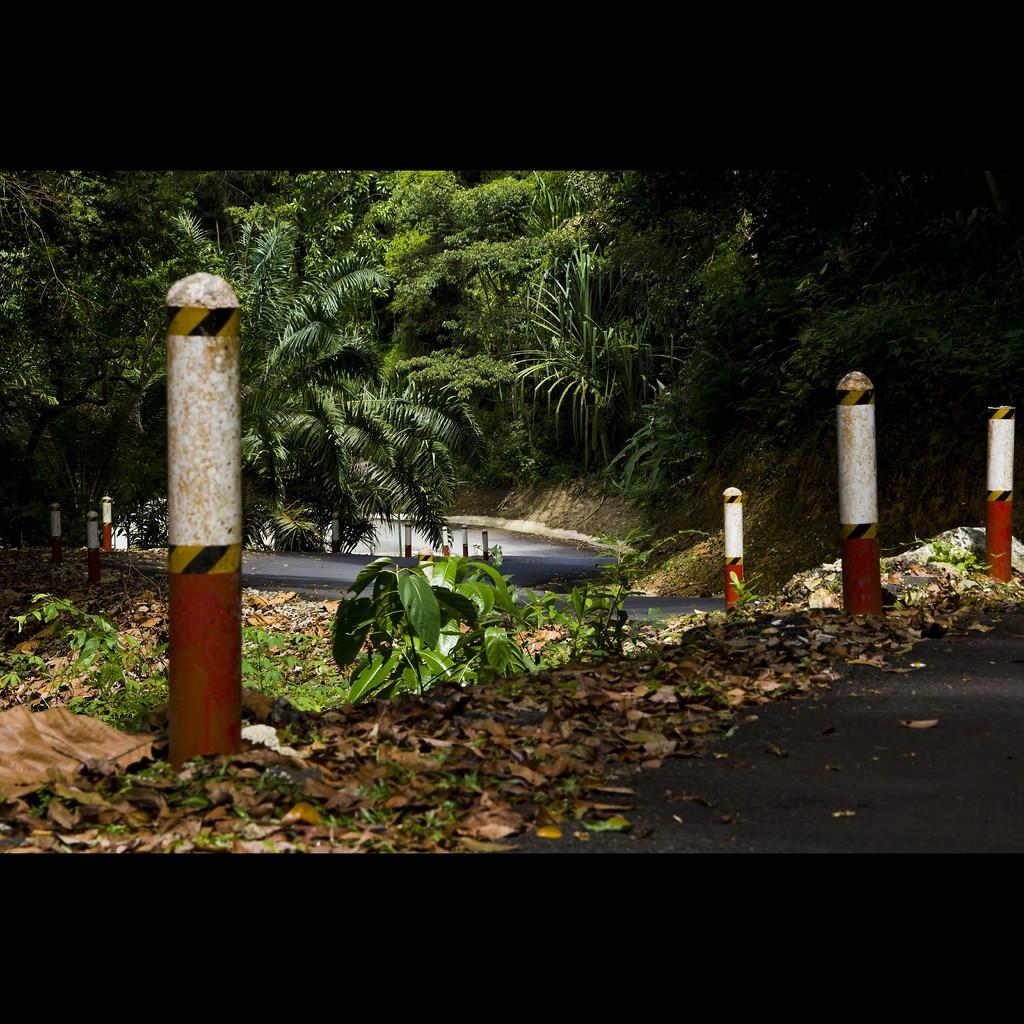What is the main feature of the image? There is a road in the image. What can be seen alongside the road? There are poles at the side of the road. What type of vegetation is visible in the image? Leaves, a plant, and trees are present in the image. How many snakes are slithering across the road in the image? There are no snakes visible in the image. What event related to death is depicted in the image? There is no event related to death depicted in the image. 